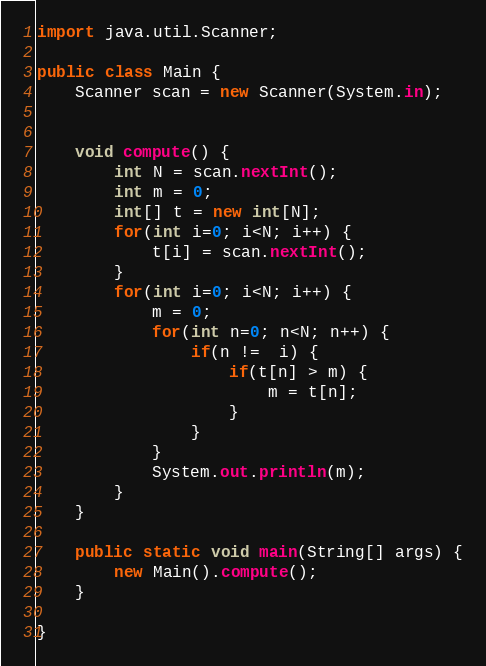Convert code to text. <code><loc_0><loc_0><loc_500><loc_500><_Java_>import java.util.Scanner;

public class Main {
	Scanner scan = new Scanner(System.in);
	
	
	void compute() {
		int N = scan.nextInt();
		int m = 0;
		int[] t = new int[N];
		for(int i=0; i<N; i++) {
			t[i] = scan.nextInt();
		}
		for(int i=0; i<N; i++) {
			m = 0;
			for(int n=0; n<N; n++) {
				if(n !=  i) {
					if(t[n] > m) {
						m = t[n];
					}
				}
			}
			System.out.println(m);
		}
	}

	public static void main(String[] args) {
		new Main().compute();
	}

}
</code> 